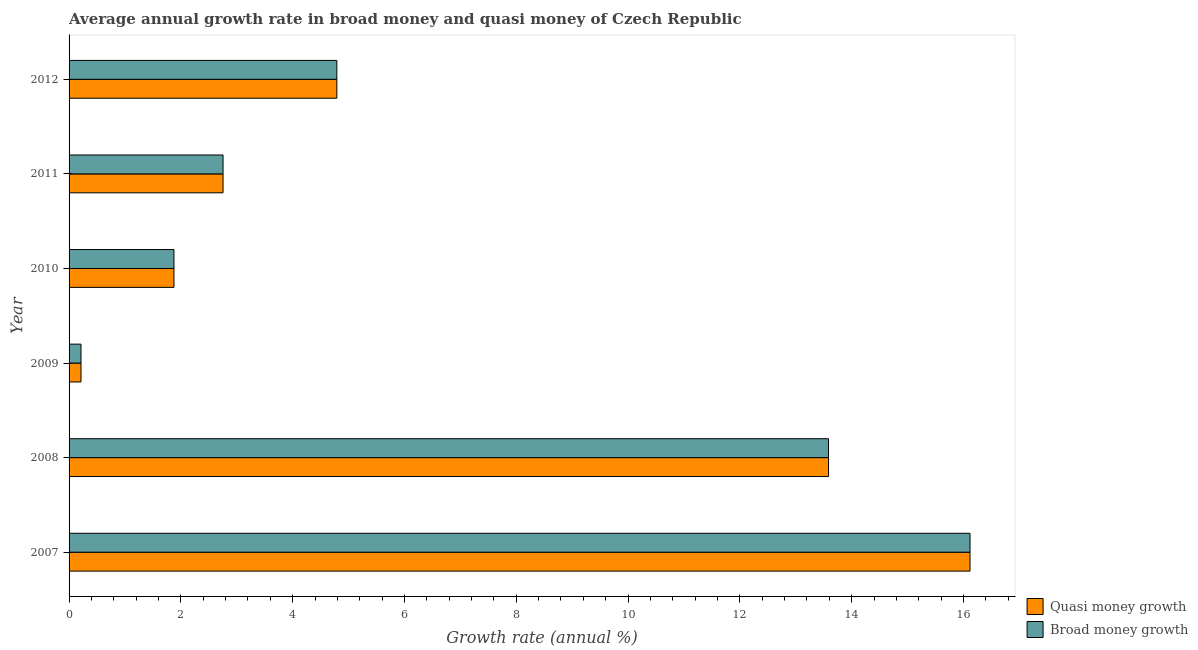How many groups of bars are there?
Offer a terse response. 6. Are the number of bars per tick equal to the number of legend labels?
Offer a terse response. Yes. Are the number of bars on each tick of the Y-axis equal?
Your answer should be compact. Yes. How many bars are there on the 1st tick from the top?
Your answer should be compact. 2. How many bars are there on the 6th tick from the bottom?
Your response must be concise. 2. What is the label of the 2nd group of bars from the top?
Keep it short and to the point. 2011. What is the annual growth rate in quasi money in 2010?
Provide a short and direct response. 1.88. Across all years, what is the maximum annual growth rate in broad money?
Your response must be concise. 16.12. Across all years, what is the minimum annual growth rate in broad money?
Make the answer very short. 0.21. In which year was the annual growth rate in quasi money maximum?
Provide a short and direct response. 2007. In which year was the annual growth rate in quasi money minimum?
Provide a succinct answer. 2009. What is the total annual growth rate in quasi money in the graph?
Offer a terse response. 39.34. What is the difference between the annual growth rate in broad money in 2007 and that in 2008?
Offer a terse response. 2.53. What is the difference between the annual growth rate in quasi money in 2011 and the annual growth rate in broad money in 2009?
Your response must be concise. 2.54. What is the average annual growth rate in quasi money per year?
Offer a very short reply. 6.56. In how many years, is the annual growth rate in broad money greater than 6.4 %?
Give a very brief answer. 2. What is the ratio of the annual growth rate in broad money in 2009 to that in 2011?
Offer a very short reply. 0.08. Is the annual growth rate in quasi money in 2008 less than that in 2011?
Offer a terse response. No. What is the difference between the highest and the second highest annual growth rate in broad money?
Provide a short and direct response. 2.53. What is the difference between the highest and the lowest annual growth rate in quasi money?
Your response must be concise. 15.9. What does the 1st bar from the top in 2010 represents?
Your answer should be very brief. Broad money growth. What does the 2nd bar from the bottom in 2012 represents?
Ensure brevity in your answer.  Broad money growth. What is the difference between two consecutive major ticks on the X-axis?
Offer a very short reply. 2. Does the graph contain any zero values?
Your answer should be compact. No. How many legend labels are there?
Your answer should be compact. 2. How are the legend labels stacked?
Make the answer very short. Vertical. What is the title of the graph?
Your answer should be compact. Average annual growth rate in broad money and quasi money of Czech Republic. Does "Nitrous oxide emissions" appear as one of the legend labels in the graph?
Provide a succinct answer. No. What is the label or title of the X-axis?
Your response must be concise. Growth rate (annual %). What is the Growth rate (annual %) of Quasi money growth in 2007?
Offer a very short reply. 16.12. What is the Growth rate (annual %) in Broad money growth in 2007?
Keep it short and to the point. 16.12. What is the Growth rate (annual %) of Quasi money growth in 2008?
Ensure brevity in your answer.  13.59. What is the Growth rate (annual %) in Broad money growth in 2008?
Your answer should be compact. 13.59. What is the Growth rate (annual %) of Quasi money growth in 2009?
Provide a succinct answer. 0.21. What is the Growth rate (annual %) in Broad money growth in 2009?
Give a very brief answer. 0.21. What is the Growth rate (annual %) of Quasi money growth in 2010?
Make the answer very short. 1.88. What is the Growth rate (annual %) of Broad money growth in 2010?
Your response must be concise. 1.88. What is the Growth rate (annual %) in Quasi money growth in 2011?
Keep it short and to the point. 2.75. What is the Growth rate (annual %) in Broad money growth in 2011?
Ensure brevity in your answer.  2.75. What is the Growth rate (annual %) in Quasi money growth in 2012?
Give a very brief answer. 4.79. What is the Growth rate (annual %) in Broad money growth in 2012?
Your answer should be very brief. 4.79. Across all years, what is the maximum Growth rate (annual %) of Quasi money growth?
Make the answer very short. 16.12. Across all years, what is the maximum Growth rate (annual %) in Broad money growth?
Ensure brevity in your answer.  16.12. Across all years, what is the minimum Growth rate (annual %) of Quasi money growth?
Ensure brevity in your answer.  0.21. Across all years, what is the minimum Growth rate (annual %) of Broad money growth?
Offer a terse response. 0.21. What is the total Growth rate (annual %) in Quasi money growth in the graph?
Your answer should be compact. 39.34. What is the total Growth rate (annual %) of Broad money growth in the graph?
Ensure brevity in your answer.  39.34. What is the difference between the Growth rate (annual %) of Quasi money growth in 2007 and that in 2008?
Your response must be concise. 2.53. What is the difference between the Growth rate (annual %) in Broad money growth in 2007 and that in 2008?
Provide a short and direct response. 2.53. What is the difference between the Growth rate (annual %) in Quasi money growth in 2007 and that in 2009?
Provide a succinct answer. 15.9. What is the difference between the Growth rate (annual %) of Broad money growth in 2007 and that in 2009?
Keep it short and to the point. 15.9. What is the difference between the Growth rate (annual %) in Quasi money growth in 2007 and that in 2010?
Offer a very short reply. 14.24. What is the difference between the Growth rate (annual %) in Broad money growth in 2007 and that in 2010?
Your answer should be compact. 14.24. What is the difference between the Growth rate (annual %) in Quasi money growth in 2007 and that in 2011?
Offer a very short reply. 13.36. What is the difference between the Growth rate (annual %) in Broad money growth in 2007 and that in 2011?
Ensure brevity in your answer.  13.36. What is the difference between the Growth rate (annual %) of Quasi money growth in 2007 and that in 2012?
Your response must be concise. 11.33. What is the difference between the Growth rate (annual %) of Broad money growth in 2007 and that in 2012?
Give a very brief answer. 11.33. What is the difference between the Growth rate (annual %) of Quasi money growth in 2008 and that in 2009?
Provide a succinct answer. 13.37. What is the difference between the Growth rate (annual %) in Broad money growth in 2008 and that in 2009?
Give a very brief answer. 13.37. What is the difference between the Growth rate (annual %) in Quasi money growth in 2008 and that in 2010?
Ensure brevity in your answer.  11.71. What is the difference between the Growth rate (annual %) of Broad money growth in 2008 and that in 2010?
Keep it short and to the point. 11.71. What is the difference between the Growth rate (annual %) of Quasi money growth in 2008 and that in 2011?
Provide a short and direct response. 10.83. What is the difference between the Growth rate (annual %) in Broad money growth in 2008 and that in 2011?
Your response must be concise. 10.83. What is the difference between the Growth rate (annual %) in Quasi money growth in 2008 and that in 2012?
Provide a short and direct response. 8.8. What is the difference between the Growth rate (annual %) of Broad money growth in 2008 and that in 2012?
Provide a succinct answer. 8.8. What is the difference between the Growth rate (annual %) in Quasi money growth in 2009 and that in 2010?
Your answer should be very brief. -1.66. What is the difference between the Growth rate (annual %) in Broad money growth in 2009 and that in 2010?
Keep it short and to the point. -1.66. What is the difference between the Growth rate (annual %) in Quasi money growth in 2009 and that in 2011?
Offer a very short reply. -2.54. What is the difference between the Growth rate (annual %) in Broad money growth in 2009 and that in 2011?
Provide a succinct answer. -2.54. What is the difference between the Growth rate (annual %) in Quasi money growth in 2009 and that in 2012?
Give a very brief answer. -4.58. What is the difference between the Growth rate (annual %) of Broad money growth in 2009 and that in 2012?
Make the answer very short. -4.58. What is the difference between the Growth rate (annual %) of Quasi money growth in 2010 and that in 2011?
Keep it short and to the point. -0.88. What is the difference between the Growth rate (annual %) of Broad money growth in 2010 and that in 2011?
Offer a terse response. -0.88. What is the difference between the Growth rate (annual %) in Quasi money growth in 2010 and that in 2012?
Offer a terse response. -2.91. What is the difference between the Growth rate (annual %) of Broad money growth in 2010 and that in 2012?
Ensure brevity in your answer.  -2.91. What is the difference between the Growth rate (annual %) of Quasi money growth in 2011 and that in 2012?
Ensure brevity in your answer.  -2.04. What is the difference between the Growth rate (annual %) of Broad money growth in 2011 and that in 2012?
Ensure brevity in your answer.  -2.04. What is the difference between the Growth rate (annual %) of Quasi money growth in 2007 and the Growth rate (annual %) of Broad money growth in 2008?
Ensure brevity in your answer.  2.53. What is the difference between the Growth rate (annual %) of Quasi money growth in 2007 and the Growth rate (annual %) of Broad money growth in 2009?
Your answer should be very brief. 15.9. What is the difference between the Growth rate (annual %) of Quasi money growth in 2007 and the Growth rate (annual %) of Broad money growth in 2010?
Provide a succinct answer. 14.24. What is the difference between the Growth rate (annual %) of Quasi money growth in 2007 and the Growth rate (annual %) of Broad money growth in 2011?
Your answer should be very brief. 13.36. What is the difference between the Growth rate (annual %) in Quasi money growth in 2007 and the Growth rate (annual %) in Broad money growth in 2012?
Your answer should be very brief. 11.33. What is the difference between the Growth rate (annual %) of Quasi money growth in 2008 and the Growth rate (annual %) of Broad money growth in 2009?
Keep it short and to the point. 13.37. What is the difference between the Growth rate (annual %) in Quasi money growth in 2008 and the Growth rate (annual %) in Broad money growth in 2010?
Offer a terse response. 11.71. What is the difference between the Growth rate (annual %) in Quasi money growth in 2008 and the Growth rate (annual %) in Broad money growth in 2011?
Give a very brief answer. 10.83. What is the difference between the Growth rate (annual %) in Quasi money growth in 2008 and the Growth rate (annual %) in Broad money growth in 2012?
Your answer should be compact. 8.8. What is the difference between the Growth rate (annual %) in Quasi money growth in 2009 and the Growth rate (annual %) in Broad money growth in 2010?
Make the answer very short. -1.66. What is the difference between the Growth rate (annual %) of Quasi money growth in 2009 and the Growth rate (annual %) of Broad money growth in 2011?
Your response must be concise. -2.54. What is the difference between the Growth rate (annual %) of Quasi money growth in 2009 and the Growth rate (annual %) of Broad money growth in 2012?
Give a very brief answer. -4.58. What is the difference between the Growth rate (annual %) of Quasi money growth in 2010 and the Growth rate (annual %) of Broad money growth in 2011?
Ensure brevity in your answer.  -0.88. What is the difference between the Growth rate (annual %) in Quasi money growth in 2010 and the Growth rate (annual %) in Broad money growth in 2012?
Your response must be concise. -2.91. What is the difference between the Growth rate (annual %) of Quasi money growth in 2011 and the Growth rate (annual %) of Broad money growth in 2012?
Keep it short and to the point. -2.04. What is the average Growth rate (annual %) of Quasi money growth per year?
Your response must be concise. 6.56. What is the average Growth rate (annual %) of Broad money growth per year?
Offer a terse response. 6.56. In the year 2007, what is the difference between the Growth rate (annual %) of Quasi money growth and Growth rate (annual %) of Broad money growth?
Offer a very short reply. 0. In the year 2010, what is the difference between the Growth rate (annual %) in Quasi money growth and Growth rate (annual %) in Broad money growth?
Your answer should be compact. 0. In the year 2012, what is the difference between the Growth rate (annual %) of Quasi money growth and Growth rate (annual %) of Broad money growth?
Offer a terse response. 0. What is the ratio of the Growth rate (annual %) in Quasi money growth in 2007 to that in 2008?
Keep it short and to the point. 1.19. What is the ratio of the Growth rate (annual %) of Broad money growth in 2007 to that in 2008?
Your answer should be very brief. 1.19. What is the ratio of the Growth rate (annual %) in Quasi money growth in 2007 to that in 2009?
Give a very brief answer. 75.55. What is the ratio of the Growth rate (annual %) of Broad money growth in 2007 to that in 2009?
Offer a terse response. 75.55. What is the ratio of the Growth rate (annual %) in Quasi money growth in 2007 to that in 2010?
Offer a terse response. 8.59. What is the ratio of the Growth rate (annual %) in Broad money growth in 2007 to that in 2010?
Your response must be concise. 8.59. What is the ratio of the Growth rate (annual %) in Quasi money growth in 2007 to that in 2011?
Offer a very short reply. 5.85. What is the ratio of the Growth rate (annual %) of Broad money growth in 2007 to that in 2011?
Your response must be concise. 5.85. What is the ratio of the Growth rate (annual %) in Quasi money growth in 2007 to that in 2012?
Keep it short and to the point. 3.36. What is the ratio of the Growth rate (annual %) in Broad money growth in 2007 to that in 2012?
Provide a succinct answer. 3.36. What is the ratio of the Growth rate (annual %) of Quasi money growth in 2008 to that in 2009?
Provide a succinct answer. 63.69. What is the ratio of the Growth rate (annual %) of Broad money growth in 2008 to that in 2009?
Keep it short and to the point. 63.69. What is the ratio of the Growth rate (annual %) of Quasi money growth in 2008 to that in 2010?
Ensure brevity in your answer.  7.24. What is the ratio of the Growth rate (annual %) of Broad money growth in 2008 to that in 2010?
Offer a terse response. 7.24. What is the ratio of the Growth rate (annual %) in Quasi money growth in 2008 to that in 2011?
Offer a terse response. 4.93. What is the ratio of the Growth rate (annual %) in Broad money growth in 2008 to that in 2011?
Provide a short and direct response. 4.93. What is the ratio of the Growth rate (annual %) of Quasi money growth in 2008 to that in 2012?
Ensure brevity in your answer.  2.84. What is the ratio of the Growth rate (annual %) in Broad money growth in 2008 to that in 2012?
Your answer should be compact. 2.84. What is the ratio of the Growth rate (annual %) in Quasi money growth in 2009 to that in 2010?
Provide a short and direct response. 0.11. What is the ratio of the Growth rate (annual %) in Broad money growth in 2009 to that in 2010?
Make the answer very short. 0.11. What is the ratio of the Growth rate (annual %) in Quasi money growth in 2009 to that in 2011?
Provide a short and direct response. 0.08. What is the ratio of the Growth rate (annual %) in Broad money growth in 2009 to that in 2011?
Make the answer very short. 0.08. What is the ratio of the Growth rate (annual %) of Quasi money growth in 2009 to that in 2012?
Provide a succinct answer. 0.04. What is the ratio of the Growth rate (annual %) in Broad money growth in 2009 to that in 2012?
Ensure brevity in your answer.  0.04. What is the ratio of the Growth rate (annual %) in Quasi money growth in 2010 to that in 2011?
Provide a short and direct response. 0.68. What is the ratio of the Growth rate (annual %) of Broad money growth in 2010 to that in 2011?
Offer a very short reply. 0.68. What is the ratio of the Growth rate (annual %) of Quasi money growth in 2010 to that in 2012?
Give a very brief answer. 0.39. What is the ratio of the Growth rate (annual %) in Broad money growth in 2010 to that in 2012?
Give a very brief answer. 0.39. What is the ratio of the Growth rate (annual %) of Quasi money growth in 2011 to that in 2012?
Make the answer very short. 0.57. What is the ratio of the Growth rate (annual %) of Broad money growth in 2011 to that in 2012?
Offer a terse response. 0.57. What is the difference between the highest and the second highest Growth rate (annual %) in Quasi money growth?
Provide a short and direct response. 2.53. What is the difference between the highest and the second highest Growth rate (annual %) in Broad money growth?
Keep it short and to the point. 2.53. What is the difference between the highest and the lowest Growth rate (annual %) of Quasi money growth?
Provide a short and direct response. 15.9. What is the difference between the highest and the lowest Growth rate (annual %) in Broad money growth?
Your answer should be compact. 15.9. 